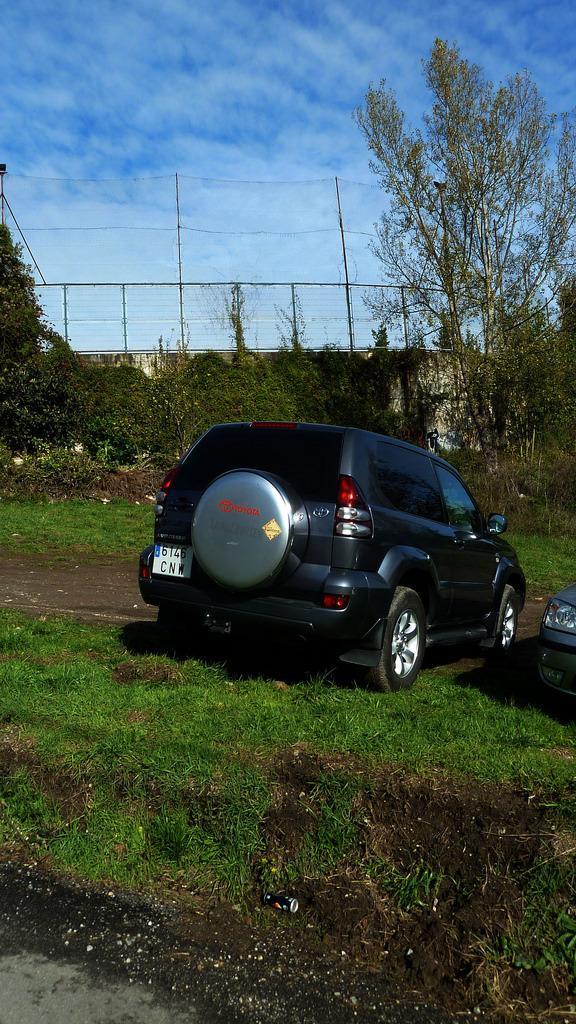Describe this image in one or two sentences. In this image in the center there is one car, at the bottom there is grass. And in the background there is a fence, net, poles and trees. At the top there is sky. 